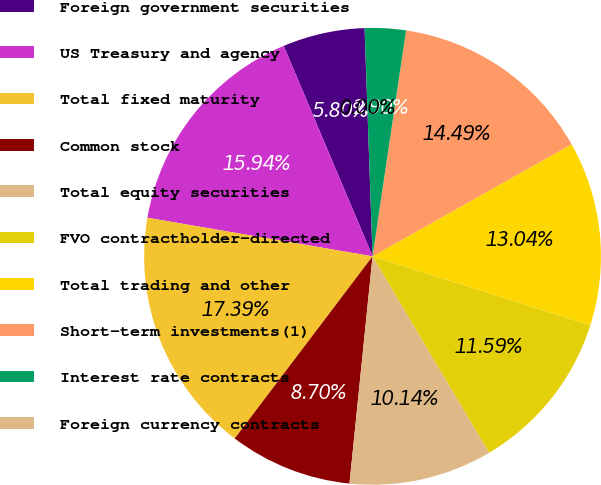Convert chart. <chart><loc_0><loc_0><loc_500><loc_500><pie_chart><fcel>Foreign government securities<fcel>US Treasury and agency<fcel>Total fixed maturity<fcel>Common stock<fcel>Total equity securities<fcel>FVO contractholder-directed<fcel>Total trading and other<fcel>Short-term investments(1)<fcel>Interest rate contracts<fcel>Foreign currency contracts<nl><fcel>5.8%<fcel>15.94%<fcel>17.39%<fcel>8.7%<fcel>10.14%<fcel>11.59%<fcel>13.04%<fcel>14.49%<fcel>2.9%<fcel>0.0%<nl></chart> 